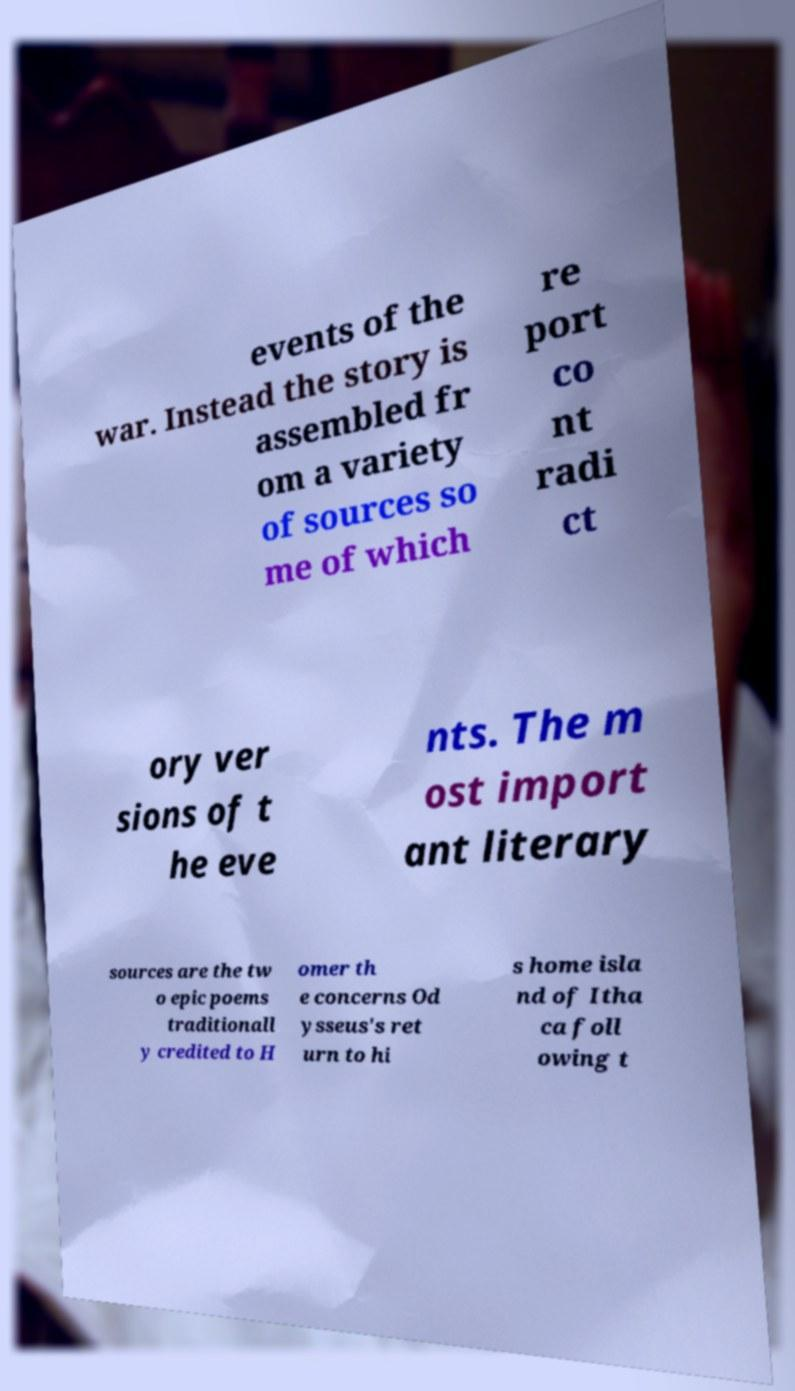Please read and relay the text visible in this image. What does it say? events of the war. Instead the story is assembled fr om a variety of sources so me of which re port co nt radi ct ory ver sions of t he eve nts. The m ost import ant literary sources are the tw o epic poems traditionall y credited to H omer th e concerns Od ysseus's ret urn to hi s home isla nd of Itha ca foll owing t 